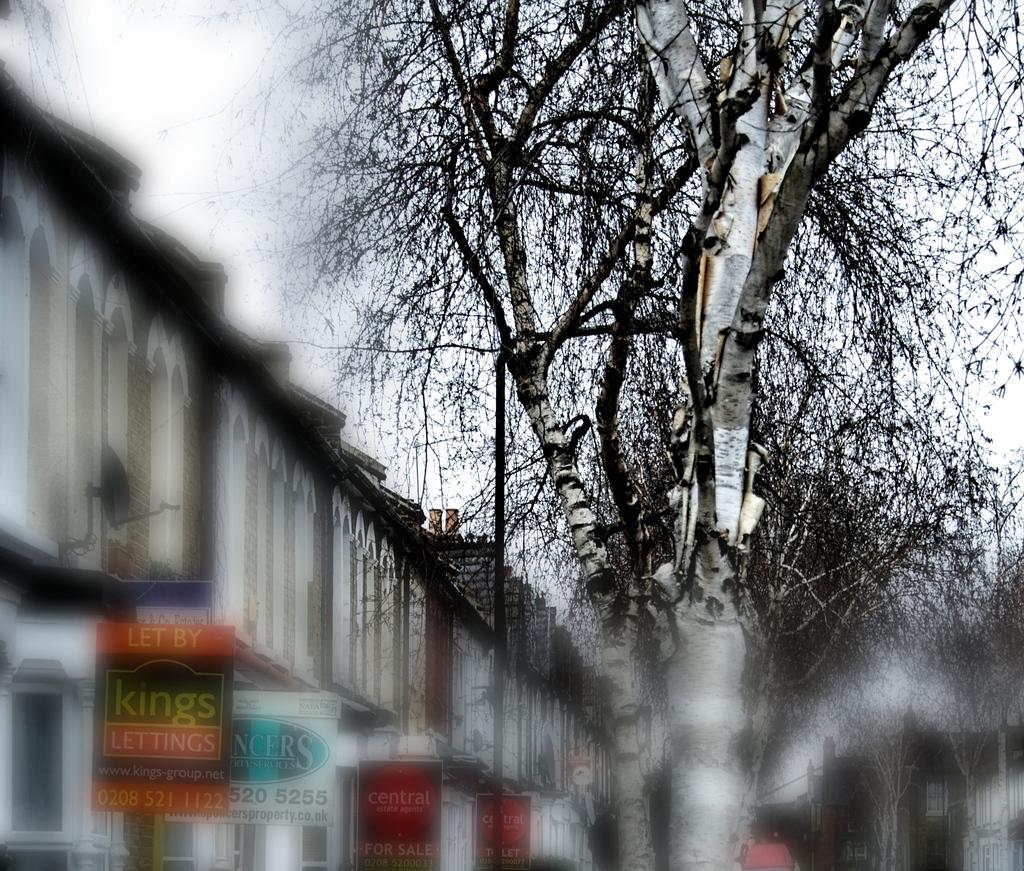What does the sign to the far left say?
Offer a very short reply. Let by kings lettings. 